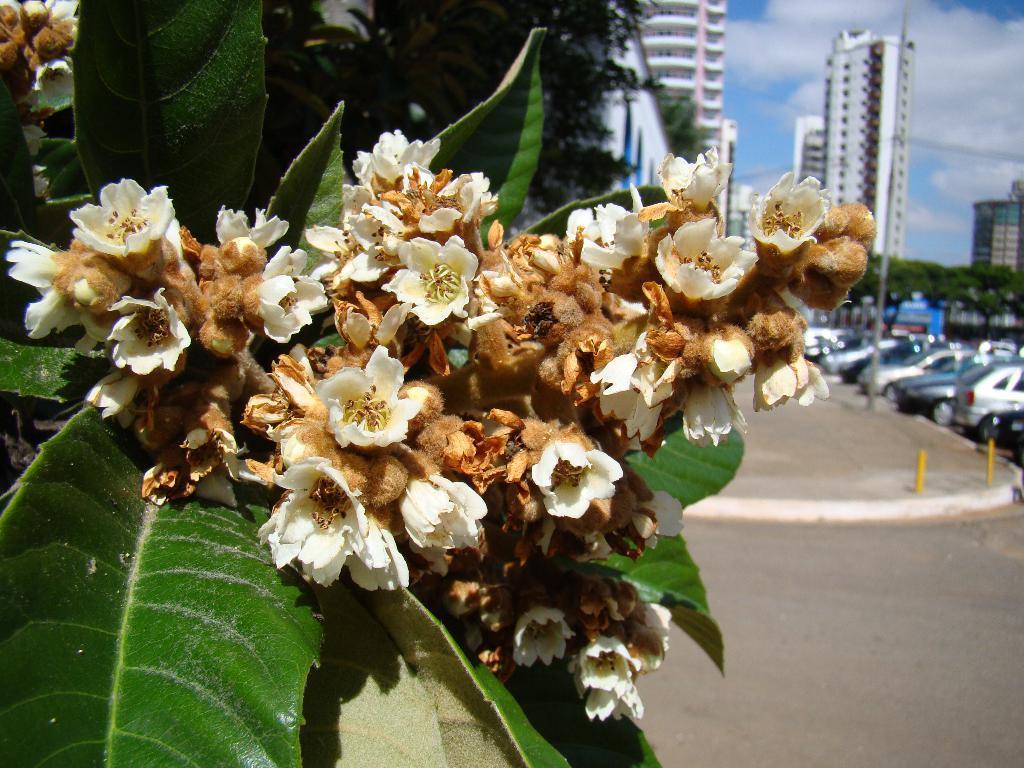Please provide a concise description of this image. Here we can see leaves and flowers. In the background there are trees,buildings,poles and clouds in the sky. On the right there are vehicles on the road. 